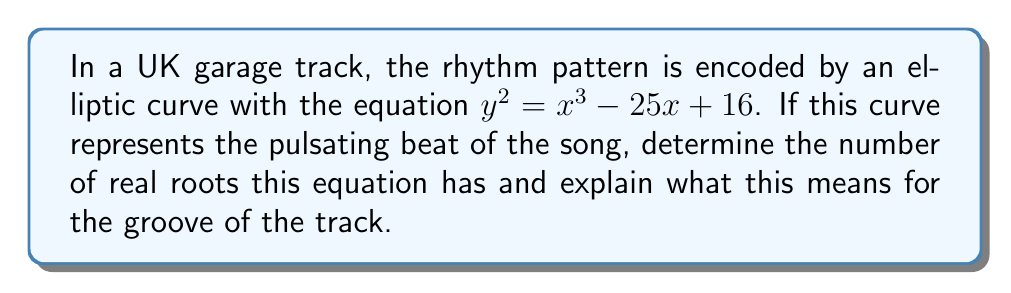Help me with this question. Let's break this down step-by-step, fam:

1) First, we need to determine the discriminant of the elliptic curve. The discriminant Δ is given by:

   $$Δ = -16(4a^3 + 27b^2)$$

   where $a$ and $b$ are the coefficients of $x$ and the constant term respectively in the Weierstrass form $y^2 = x^3 + ax + b$.

2) In our case, $a = -25$ and $b = 16$. Let's plug these into the discriminant formula:

   $$Δ = -16(4(-25)^3 + 27(16)^2)$$
   $$= -16(-62500 + 6912)$$
   $$= -16(-55588)$$
   $$= 889408$$

3) The discriminant is positive, which is absolutely fire! This means our elliptic curve has three distinct real roots.

4) In the context of our UK garage track, these three roots represent three distinct beat patterns or rhythmic elements in the song. It's like having a sick triple-time flow!

5) Geometrically, this means our elliptic curve intersects the x-axis at three different points, creating a wavy pattern that mimics the undulating rhythm of the track.

[asy]
import graph;
size(200,200);
real f(real x) {return sqrt(x^3 - 25x + 16);}
real g(real x) {return -sqrt(x^3 - 25x + 16);}
draw(graph(f,-5,5),blue);
draw(graph(g,-5,5),blue);
xaxis("x");
yaxis("y");
[/asy]

6) The positive discriminant also indicates that the curve is non-singular, meaning our rhythm stays smooth and continuous throughout the track, keeping the vibe consistent and the crowd moving!
Answer: 3 real roots; represents 3 distinct rhythmic elements 